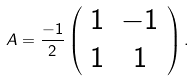Convert formula to latex. <formula><loc_0><loc_0><loc_500><loc_500>A = \frac { - 1 } { 2 } \left ( \begin{array} { c c } 1 & - 1 \\ 1 & 1 \end{array} \right ) .</formula> 